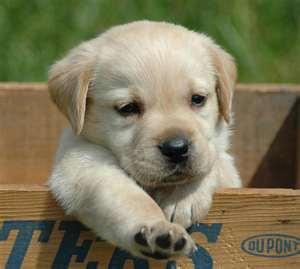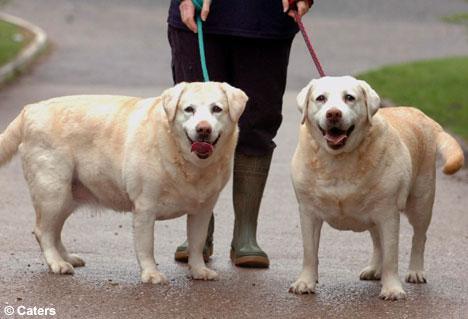The first image is the image on the left, the second image is the image on the right. For the images shown, is this caption "In one image, a puppy is leaning over a wooden ledge with only its head and front paws visible." true? Answer yes or no. Yes. The first image is the image on the left, the second image is the image on the right. Analyze the images presented: Is the assertion "In 1 of the images, 1 dog is leaning over the edge of a wooden box." valid? Answer yes or no. Yes. 